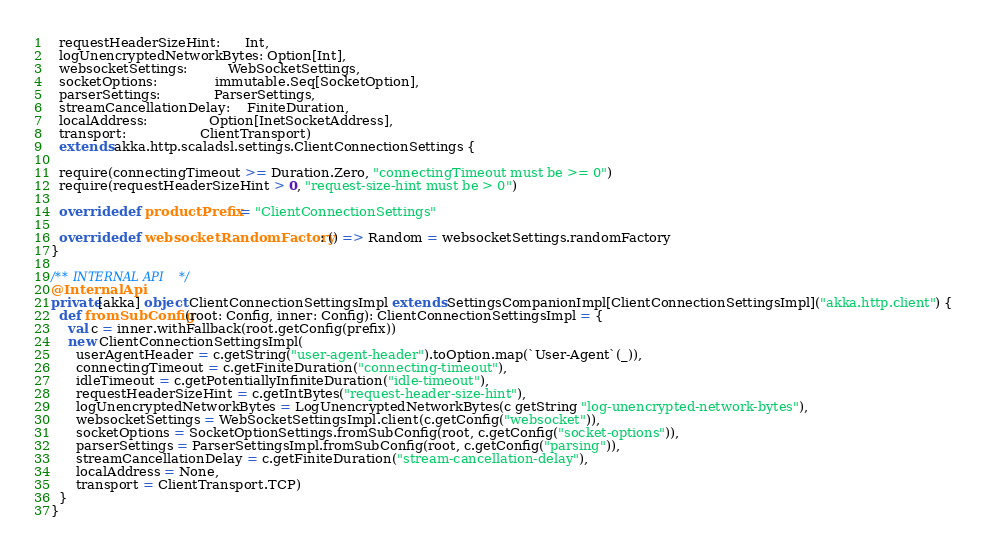<code> <loc_0><loc_0><loc_500><loc_500><_Scala_>  requestHeaderSizeHint:      Int,
  logUnencryptedNetworkBytes: Option[Int],
  websocketSettings:          WebSocketSettings,
  socketOptions:              immutable.Seq[SocketOption],
  parserSettings:             ParserSettings,
  streamCancellationDelay:    FiniteDuration,
  localAddress:               Option[InetSocketAddress],
  transport:                  ClientTransport)
  extends akka.http.scaladsl.settings.ClientConnectionSettings {

  require(connectingTimeout >= Duration.Zero, "connectingTimeout must be >= 0")
  require(requestHeaderSizeHint > 0, "request-size-hint must be > 0")

  override def productPrefix = "ClientConnectionSettings"

  override def websocketRandomFactory: () => Random = websocketSettings.randomFactory
}

/** INTERNAL API */
@InternalApi
private[akka] object ClientConnectionSettingsImpl extends SettingsCompanionImpl[ClientConnectionSettingsImpl]("akka.http.client") {
  def fromSubConfig(root: Config, inner: Config): ClientConnectionSettingsImpl = {
    val c = inner.withFallback(root.getConfig(prefix))
    new ClientConnectionSettingsImpl(
      userAgentHeader = c.getString("user-agent-header").toOption.map(`User-Agent`(_)),
      connectingTimeout = c.getFiniteDuration("connecting-timeout"),
      idleTimeout = c.getPotentiallyInfiniteDuration("idle-timeout"),
      requestHeaderSizeHint = c.getIntBytes("request-header-size-hint"),
      logUnencryptedNetworkBytes = LogUnencryptedNetworkBytes(c getString "log-unencrypted-network-bytes"),
      websocketSettings = WebSocketSettingsImpl.client(c.getConfig("websocket")),
      socketOptions = SocketOptionSettings.fromSubConfig(root, c.getConfig("socket-options")),
      parserSettings = ParserSettingsImpl.fromSubConfig(root, c.getConfig("parsing")),
      streamCancellationDelay = c.getFiniteDuration("stream-cancellation-delay"),
      localAddress = None,
      transport = ClientTransport.TCP)
  }
}
</code> 